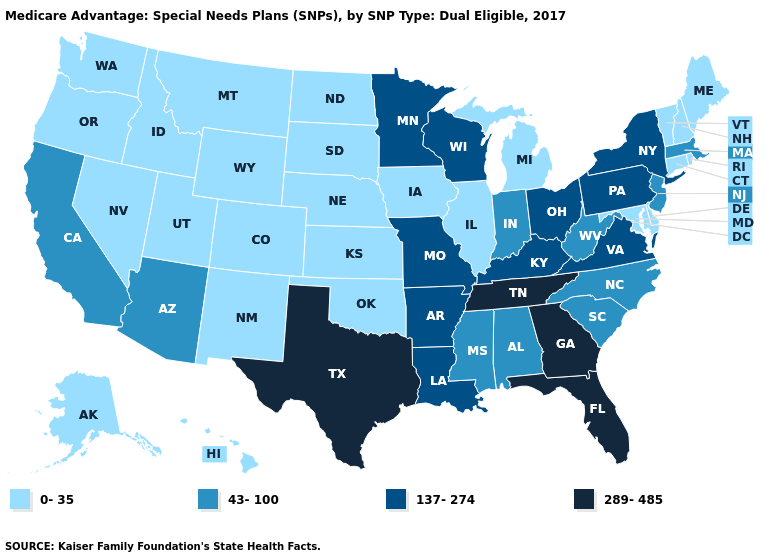Which states have the lowest value in the USA?
Be succinct. Alaska, Colorado, Connecticut, Delaware, Hawaii, Iowa, Idaho, Illinois, Kansas, Maryland, Maine, Michigan, Montana, North Dakota, Nebraska, New Hampshire, New Mexico, Nevada, Oklahoma, Oregon, Rhode Island, South Dakota, Utah, Vermont, Washington, Wyoming. What is the value of Rhode Island?
Short answer required. 0-35. What is the lowest value in the USA?
Write a very short answer. 0-35. What is the lowest value in the USA?
Answer briefly. 0-35. Does the first symbol in the legend represent the smallest category?
Quick response, please. Yes. Does New Mexico have the same value as West Virginia?
Give a very brief answer. No. Among the states that border Mississippi , which have the highest value?
Give a very brief answer. Tennessee. Among the states that border Wisconsin , which have the lowest value?
Keep it brief. Iowa, Illinois, Michigan. Does South Dakota have the highest value in the USA?
Give a very brief answer. No. Does Oregon have a lower value than Kansas?
Answer briefly. No. Does the map have missing data?
Quick response, please. No. Does the map have missing data?
Write a very short answer. No. What is the value of Missouri?
Concise answer only. 137-274. What is the value of California?
Short answer required. 43-100. Does Delaware have the lowest value in the South?
Quick response, please. Yes. 